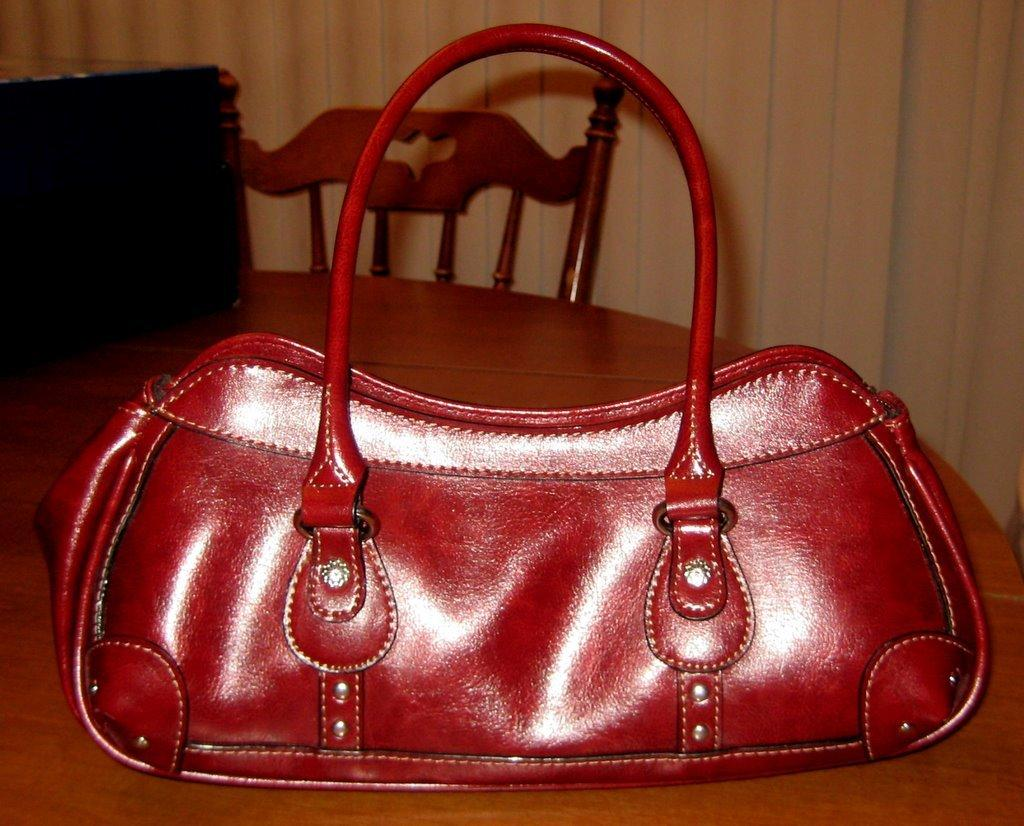What object is present on the table in the image? There is a bag on the table in the image. What type of chalk is being used by the secretary in the image? There is no secretary or chalk present in the image; it only features a bag on a table. 